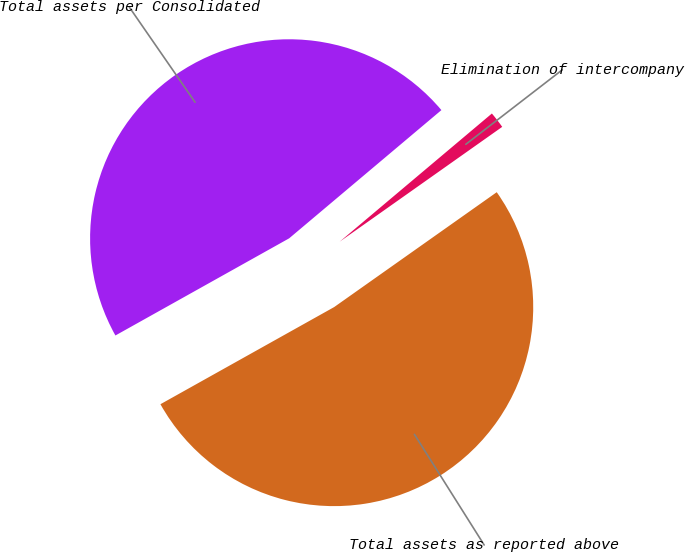<chart> <loc_0><loc_0><loc_500><loc_500><pie_chart><fcel>Total assets as reported above<fcel>Elimination of intercompany<fcel>Total assets per Consolidated<nl><fcel>51.67%<fcel>1.35%<fcel>46.97%<nl></chart> 